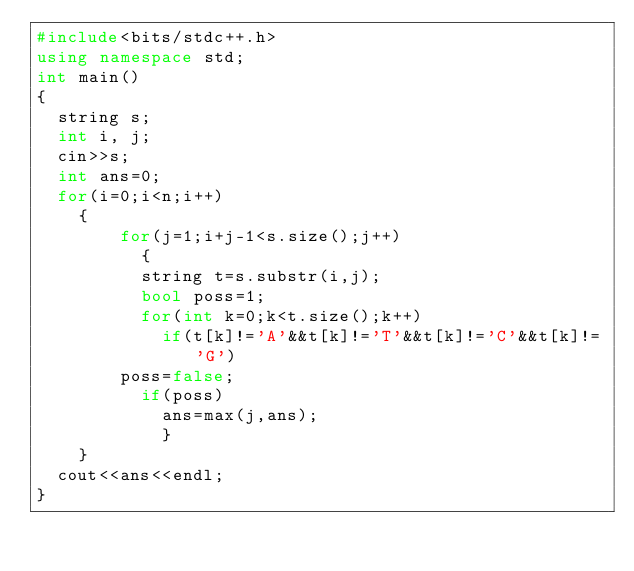<code> <loc_0><loc_0><loc_500><loc_500><_C++_>#include<bits/stdc++.h>
using namespace std;
int main()
{
  string s;
  int i, j;
  cin>>s;
  int ans=0;
  for(i=0;i<n;i++)
    {
        for(j=1;i+j-1<s.size();j++)
          {
          string t=s.substr(i,j);
          bool poss=1;
          for(int k=0;k<t.size();k++)
            if(t[k]!='A'&&t[k]!='T'&&t[k]!='C'&&t[k]!='G')  
        poss=false;
          if(poss)
            ans=max(j,ans);
            }
    }
  cout<<ans<<endl;
}</code> 